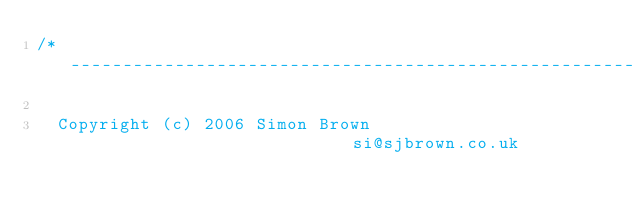<code> <loc_0><loc_0><loc_500><loc_500><_C++_>/* -----------------------------------------------------------------------------

	Copyright (c) 2006 Simon Brown                          si@sjbrown.co.uk
</code> 